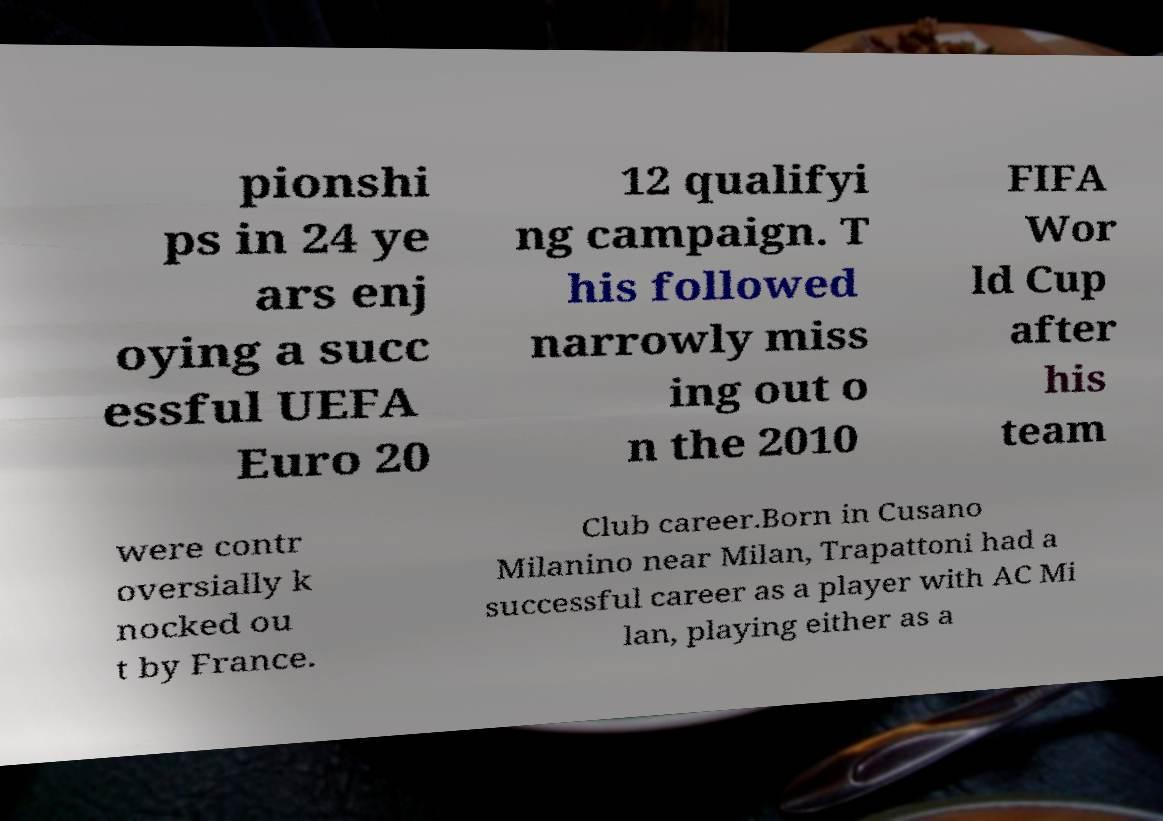Can you accurately transcribe the text from the provided image for me? pionshi ps in 24 ye ars enj oying a succ essful UEFA Euro 20 12 qualifyi ng campaign. T his followed narrowly miss ing out o n the 2010 FIFA Wor ld Cup after his team were contr oversially k nocked ou t by France. Club career.Born in Cusano Milanino near Milan, Trapattoni had a successful career as a player with AC Mi lan, playing either as a 